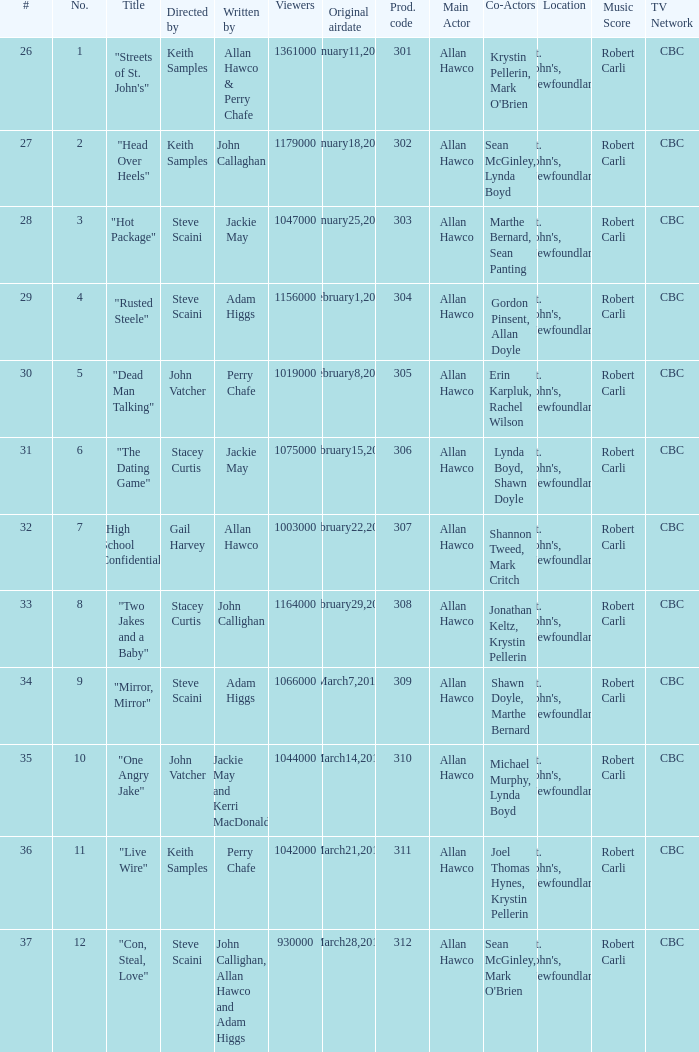What is the total number of films directy and written by john callaghan? 1.0. 